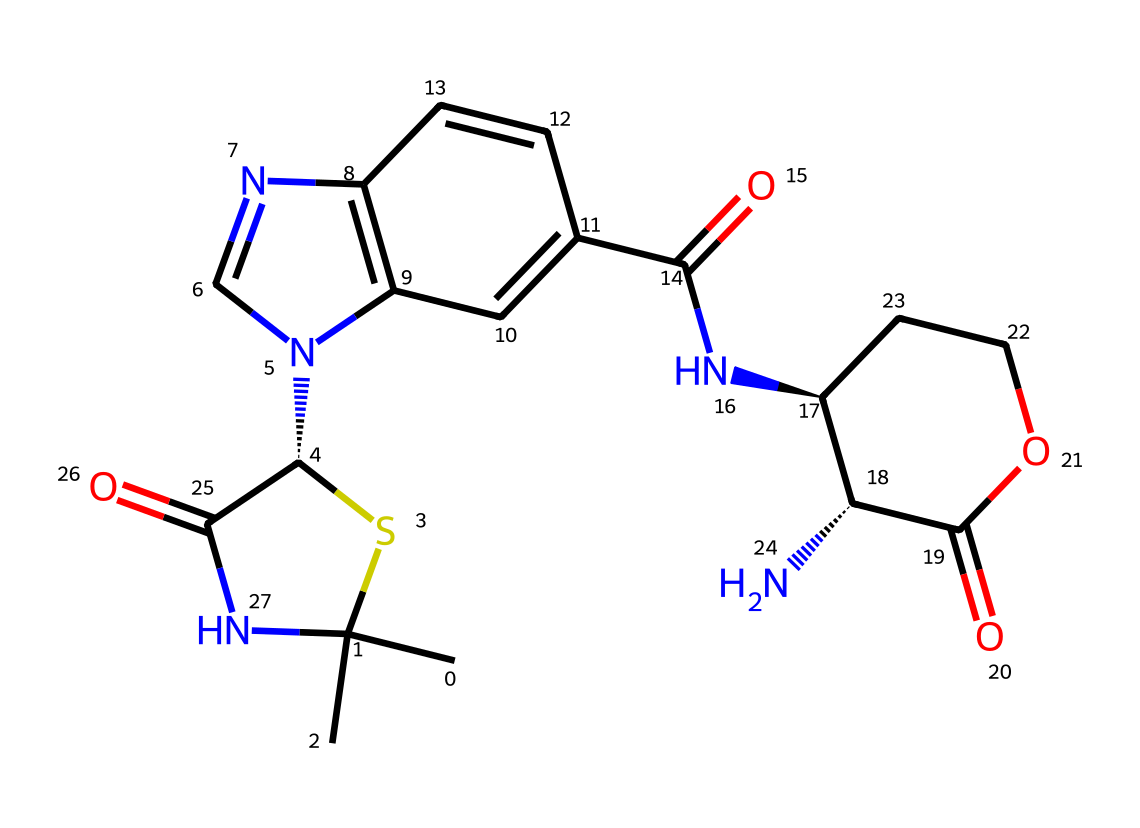What is the central atom in the structure? The central atom in the structure is sulfur (S), as it can be identified in the cyclic part of the compound where it is attached to carbon atoms.
Answer: sulfur How many nitrogen atoms are present in the chemical? The chemical structure contains four nitrogen (N) atoms, which can be counted in the various functional groups and rings throughout the structure.
Answer: four What is the functional group present in the structure? The chemical features multiple functional groups including an amide group (C(=O)N) and a carboxylic acid group (C(=O)O), identifiable from their specific structural components.
Answer: amide and carboxylic acid What type of drug does this structure represent? This structure represents a beta-lactam antibiotic, specifically a penicillin derivative, as it has the characteristic beta-lactam ring and functional groups associated with penicillin-type antibiotics.
Answer: beta-lactam antibiotic Which part of the chemical structure contributes to its antibacterial properties? The beta-lactam ring is critical for the antibacterial properties, as it interacts with bacterial cell wall synthesis enzymes, inhibiting their function.
Answer: beta-lactam ring How many rings are present in the structure? The chemical structure contains three rings, which can be determined by examining the cyclic portions of the molecule that include fused ring systems.
Answer: three 